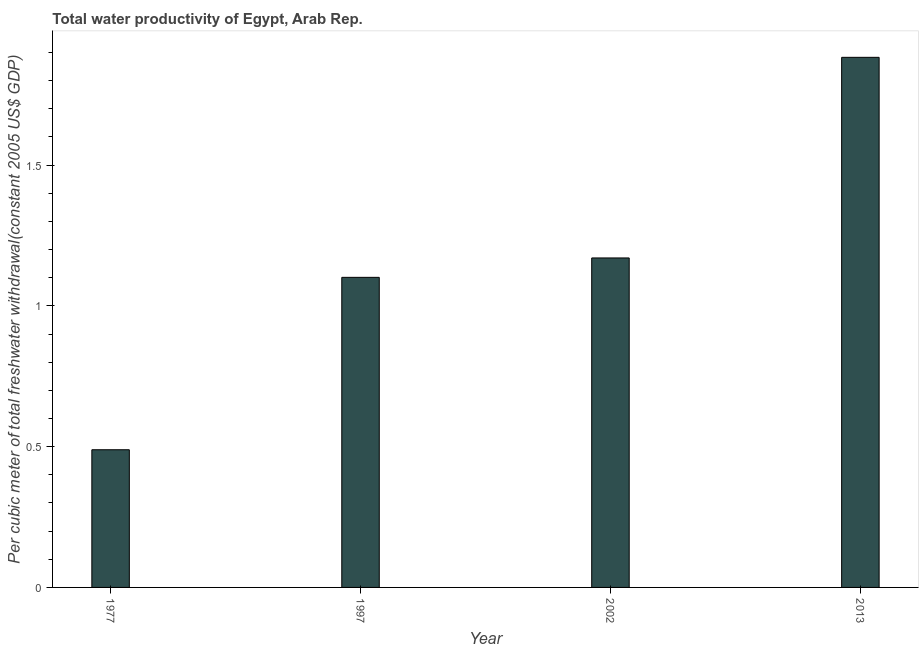Does the graph contain any zero values?
Your answer should be very brief. No. What is the title of the graph?
Ensure brevity in your answer.  Total water productivity of Egypt, Arab Rep. What is the label or title of the X-axis?
Your answer should be very brief. Year. What is the label or title of the Y-axis?
Give a very brief answer. Per cubic meter of total freshwater withdrawal(constant 2005 US$ GDP). What is the total water productivity in 2013?
Make the answer very short. 1.88. Across all years, what is the maximum total water productivity?
Your answer should be very brief. 1.88. Across all years, what is the minimum total water productivity?
Your answer should be compact. 0.49. In which year was the total water productivity minimum?
Ensure brevity in your answer.  1977. What is the sum of the total water productivity?
Provide a succinct answer. 4.64. What is the difference between the total water productivity in 1977 and 2013?
Give a very brief answer. -1.39. What is the average total water productivity per year?
Offer a terse response. 1.16. What is the median total water productivity?
Your response must be concise. 1.14. Do a majority of the years between 1977 and 2013 (inclusive) have total water productivity greater than 0.8 US$?
Ensure brevity in your answer.  Yes. What is the ratio of the total water productivity in 1977 to that in 1997?
Your answer should be compact. 0.44. Is the total water productivity in 1977 less than that in 1997?
Offer a terse response. Yes. What is the difference between the highest and the second highest total water productivity?
Offer a very short reply. 0.71. What is the difference between the highest and the lowest total water productivity?
Ensure brevity in your answer.  1.39. How many years are there in the graph?
Offer a terse response. 4. Are the values on the major ticks of Y-axis written in scientific E-notation?
Give a very brief answer. No. What is the Per cubic meter of total freshwater withdrawal(constant 2005 US$ GDP) in 1977?
Offer a terse response. 0.49. What is the Per cubic meter of total freshwater withdrawal(constant 2005 US$ GDP) of 1997?
Your response must be concise. 1.1. What is the Per cubic meter of total freshwater withdrawal(constant 2005 US$ GDP) in 2002?
Your answer should be compact. 1.17. What is the Per cubic meter of total freshwater withdrawal(constant 2005 US$ GDP) of 2013?
Your response must be concise. 1.88. What is the difference between the Per cubic meter of total freshwater withdrawal(constant 2005 US$ GDP) in 1977 and 1997?
Give a very brief answer. -0.61. What is the difference between the Per cubic meter of total freshwater withdrawal(constant 2005 US$ GDP) in 1977 and 2002?
Provide a short and direct response. -0.68. What is the difference between the Per cubic meter of total freshwater withdrawal(constant 2005 US$ GDP) in 1977 and 2013?
Give a very brief answer. -1.39. What is the difference between the Per cubic meter of total freshwater withdrawal(constant 2005 US$ GDP) in 1997 and 2002?
Offer a very short reply. -0.07. What is the difference between the Per cubic meter of total freshwater withdrawal(constant 2005 US$ GDP) in 1997 and 2013?
Your answer should be compact. -0.78. What is the difference between the Per cubic meter of total freshwater withdrawal(constant 2005 US$ GDP) in 2002 and 2013?
Your response must be concise. -0.71. What is the ratio of the Per cubic meter of total freshwater withdrawal(constant 2005 US$ GDP) in 1977 to that in 1997?
Your response must be concise. 0.44. What is the ratio of the Per cubic meter of total freshwater withdrawal(constant 2005 US$ GDP) in 1977 to that in 2002?
Give a very brief answer. 0.42. What is the ratio of the Per cubic meter of total freshwater withdrawal(constant 2005 US$ GDP) in 1977 to that in 2013?
Provide a succinct answer. 0.26. What is the ratio of the Per cubic meter of total freshwater withdrawal(constant 2005 US$ GDP) in 1997 to that in 2002?
Offer a very short reply. 0.94. What is the ratio of the Per cubic meter of total freshwater withdrawal(constant 2005 US$ GDP) in 1997 to that in 2013?
Your answer should be very brief. 0.58. What is the ratio of the Per cubic meter of total freshwater withdrawal(constant 2005 US$ GDP) in 2002 to that in 2013?
Make the answer very short. 0.62. 